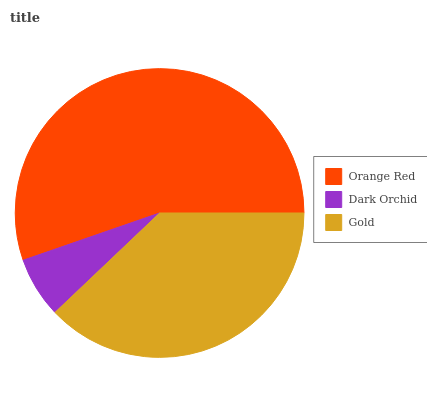Is Dark Orchid the minimum?
Answer yes or no. Yes. Is Orange Red the maximum?
Answer yes or no. Yes. Is Gold the minimum?
Answer yes or no. No. Is Gold the maximum?
Answer yes or no. No. Is Gold greater than Dark Orchid?
Answer yes or no. Yes. Is Dark Orchid less than Gold?
Answer yes or no. Yes. Is Dark Orchid greater than Gold?
Answer yes or no. No. Is Gold less than Dark Orchid?
Answer yes or no. No. Is Gold the high median?
Answer yes or no. Yes. Is Gold the low median?
Answer yes or no. Yes. Is Orange Red the high median?
Answer yes or no. No. Is Dark Orchid the low median?
Answer yes or no. No. 